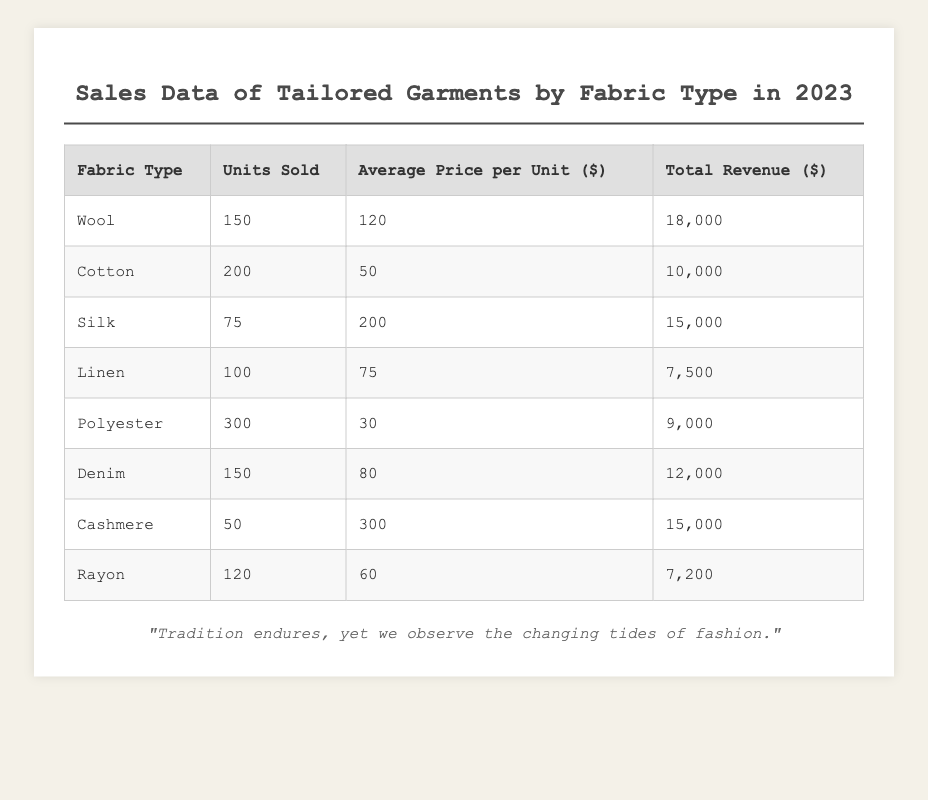What is the total number of units sold across all fabric types? To find the total units sold, we need to sum the units sold for each fabric type: 150 (Wool) + 200 (Cotton) + 75 (Silk) + 100 (Linen) + 300 (Polyester) + 150 (Denim) + 50 (Cashmere) + 120 (Rayon) = 1,145.
Answer: 1,145 Which fabric type generated the highest revenue? The highest total revenue among the fabric types is found by comparing the total revenue values: Wool ($18,000), Cotton ($10,000), Silk ($15,000), Linen ($7,500), Polyester ($9,000), Denim ($12,000), Cashmere ($15,000), Rayon ($7,200). Wool has the highest revenue at $18,000.
Answer: Wool What is the average price per unit for all fabric types? First, we find the total revenue, which is $18,000 (Wool) + $10,000 (Cotton) + $15,000 (Silk) + $7,500 (Linen) + $9,000 (Polyester) + $12,000 (Denim) + $15,000 (Cashmere) + $7,200 (Rayon) = $93,700. Next, we divide this by the total units sold (1,145) to get the average price per unit: $93,700 / 1,145 ≈ $81.92.
Answer: $81.92 How many more units of Cotton were sold compared to Cashmere? The number of units sold for Cotton is 200 and for Cashmere is 50. To find the difference, we subtract Cashmere's units from Cotton's: 200 - 50 = 150.
Answer: 150 Is Denim cheaper per unit on average than Polyester? The average price per unit for Denim is $80, and for Polyester, it is $30. Since $80 is greater than $30, Denim is not cheaper than Polyester.
Answer: No What is the total revenue from Wool and Cashmere combined? To find the combined revenue, we look at Wool's revenue ($18,000) and Cashmere's revenue ($15,000) and sum them: $18,000 + $15,000 = $33,000.
Answer: $33,000 What percentage of the total units sold were Silk? First, we note that Silk sold 75 units. We then calculate the percentage by taking (75 / 1,145) * 100 ≈ 6.55%.
Answer: 6.55% What fabric type has the lowest average price per unit and what is that price? Checking the average prices: Wool ($120), Cotton ($50), Silk ($200), Linen ($75), Polyester ($30), Denim ($80), Cashmere ($300), Rayon ($60). Polyester has the lowest average price at $30.
Answer: Polyester, $30 If we combine units sold of Wool and Silk, what would be the total? Wool sold 150 units, and Silk sold 75 units. Thus, the total is 150 + 75 = 225 units.
Answer: 225 Which fabric type has the highest average price per unit? Looking through the average prices: Wool ($120), Cotton ($50), Silk ($200), Linen ($75), Polyester ($30), Denim ($80), Cashmere ($300), Rayon ($60). Cashmere has the highest average price at $300.
Answer: Cashmere 